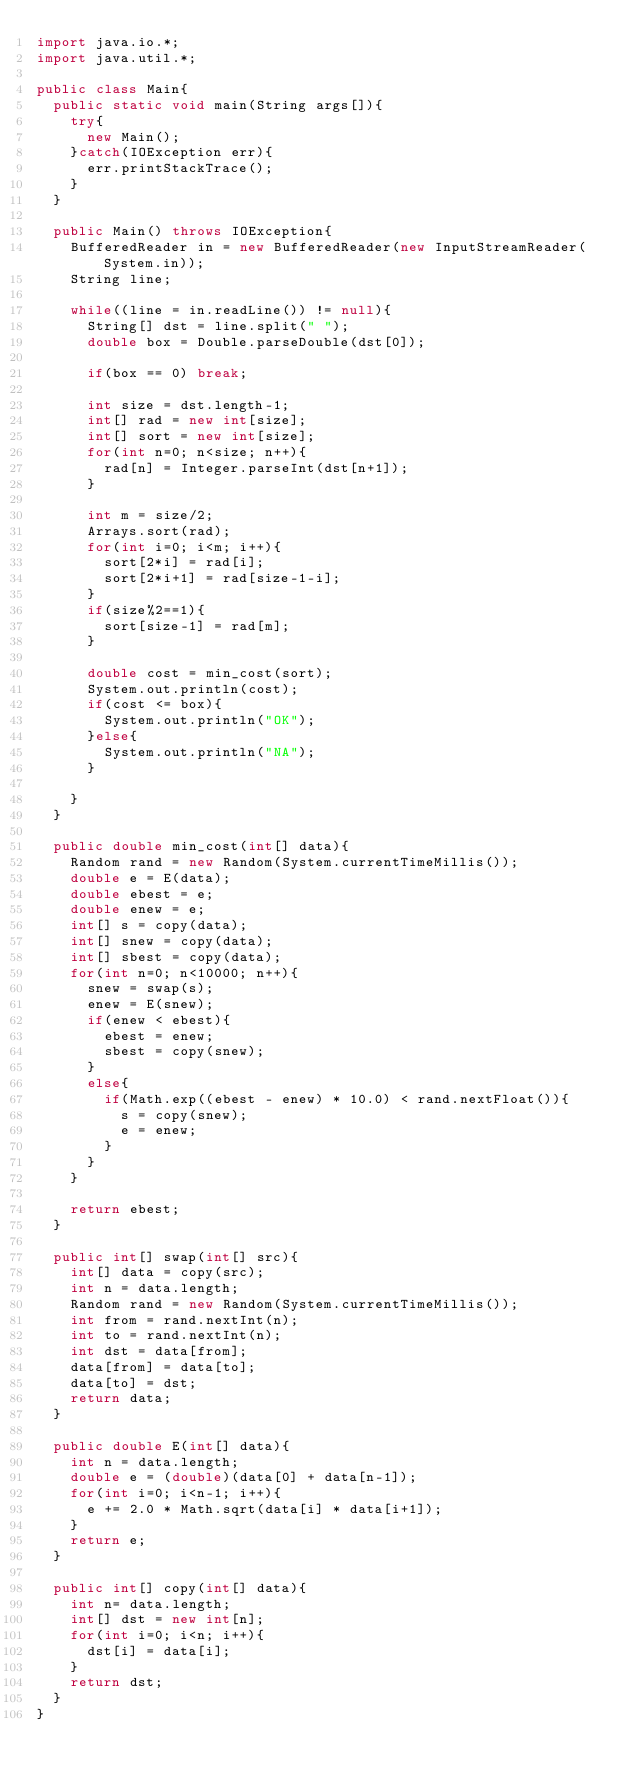Convert code to text. <code><loc_0><loc_0><loc_500><loc_500><_Java_>import java.io.*;
import java.util.*;

public class Main{
	public static void main(String args[]){
		try{
			new Main();
		}catch(IOException err){
			err.printStackTrace();
		}
	}

	public Main() throws IOException{
		BufferedReader in = new BufferedReader(new InputStreamReader(System.in));
		String line;

		while((line = in.readLine()) != null){
			String[] dst = line.split(" ");
			double box = Double.parseDouble(dst[0]);

			if(box == 0) break;

			int size = dst.length-1;
			int[] rad = new int[size];
			int[] sort = new int[size];
			for(int n=0; n<size; n++){
				rad[n] = Integer.parseInt(dst[n+1]);
			}

			int m = size/2;
			Arrays.sort(rad);
			for(int i=0; i<m; i++){
				sort[2*i] = rad[i];
				sort[2*i+1] = rad[size-1-i];
			}
			if(size%2==1){
				sort[size-1] = rad[m];
			}

			double cost = min_cost(sort);
			System.out.println(cost);
			if(cost <= box){
				System.out.println("OK");
			}else{
				System.out.println("NA");
			}

		}
	}

	public double min_cost(int[] data){
		Random rand = new Random(System.currentTimeMillis());
		double e = E(data);
		double ebest = e;
		double enew = e;
		int[] s = copy(data);
		int[] snew = copy(data);
		int[] sbest = copy(data);
		for(int n=0; n<10000; n++){
			snew = swap(s);
			enew = E(snew);
			if(enew < ebest){
				ebest = enew;
				sbest = copy(snew);
			}
			else{
				if(Math.exp((ebest - enew) * 10.0) < rand.nextFloat()){
					s = copy(snew);
					e = enew;
				}
			}
		}

		return ebest;
	}

	public int[] swap(int[] src){
		int[] data = copy(src);
		int n = data.length;
		Random rand = new Random(System.currentTimeMillis());
		int from = rand.nextInt(n);
		int to = rand.nextInt(n);
		int dst = data[from];
		data[from] = data[to];
		data[to] = dst;
		return data;
	}

	public double E(int[] data){
		int n = data.length;
		double e = (double)(data[0] + data[n-1]);
		for(int i=0; i<n-1; i++){
			e += 2.0 * Math.sqrt(data[i] * data[i+1]);
		}
		return e;
	}

	public int[] copy(int[] data){
		int n= data.length;
		int[] dst = new int[n];
		for(int i=0; i<n; i++){
			dst[i] = data[i];
		}
		return dst;
	}
}</code> 